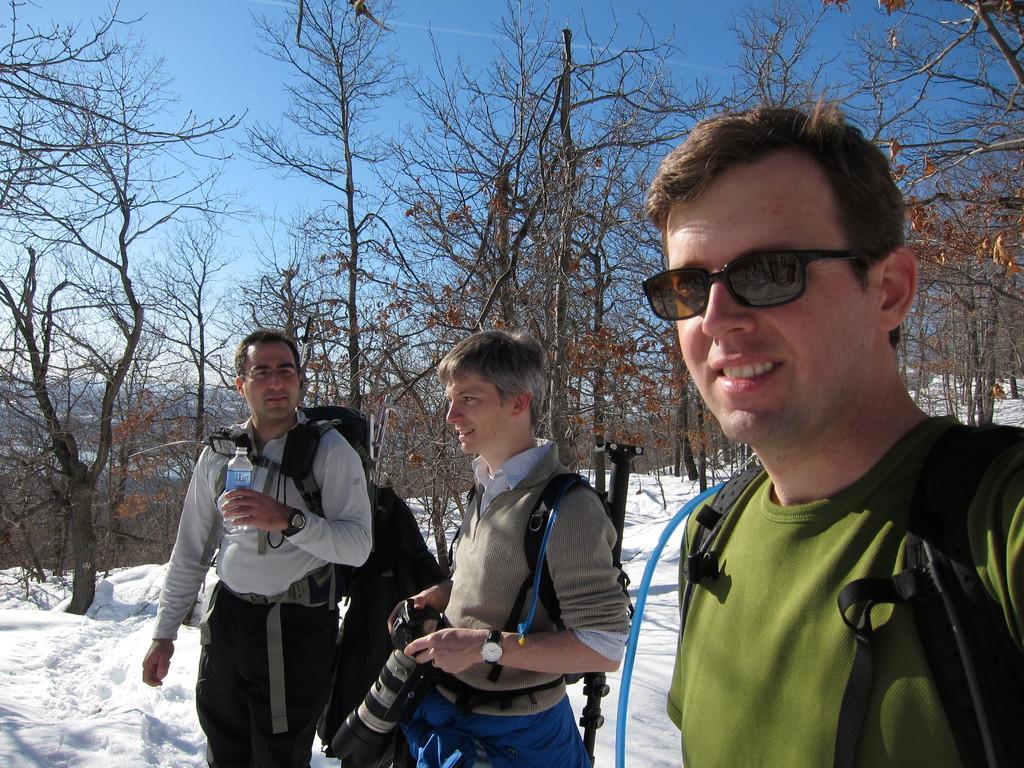How would you summarize this image in a sentence or two? In the image we can see there are people who are standing on the snow and at the back there are lot of trees. 